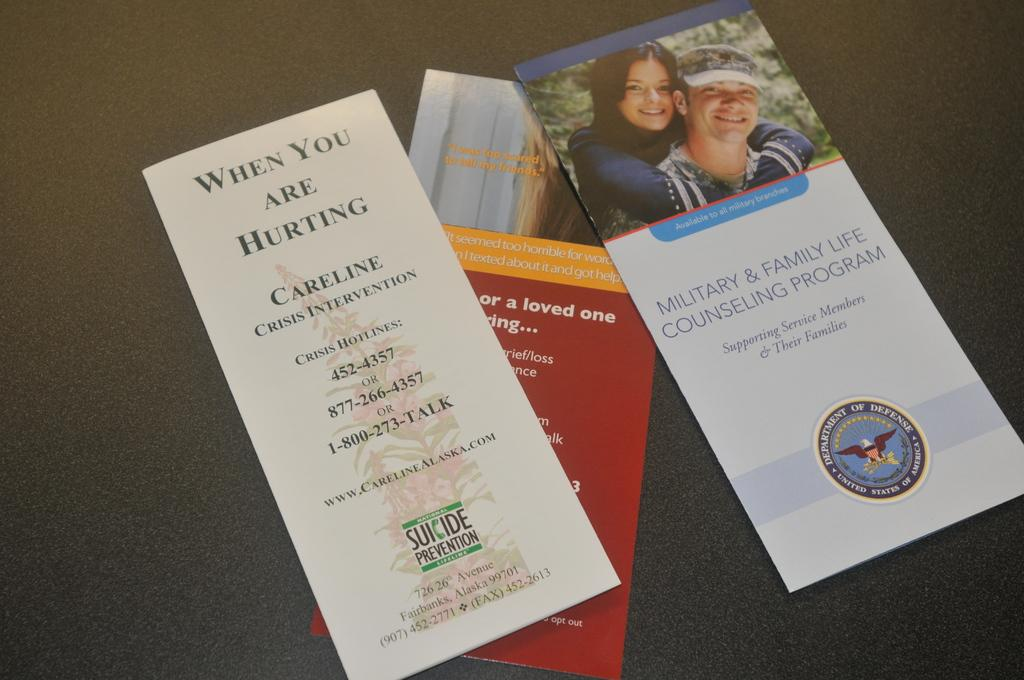What can be seen on the posters in the image? The posters have text and images on them. Where are the posters located in the image? The posters are placed on a surface. What type of mine is depicted in the image? There is no mine present in the image; it features posters with text and images. What kind of drug is being advertised on the posters in the image? There is no drug being advertised on the posters in the image; they contain text and images on various topics. 